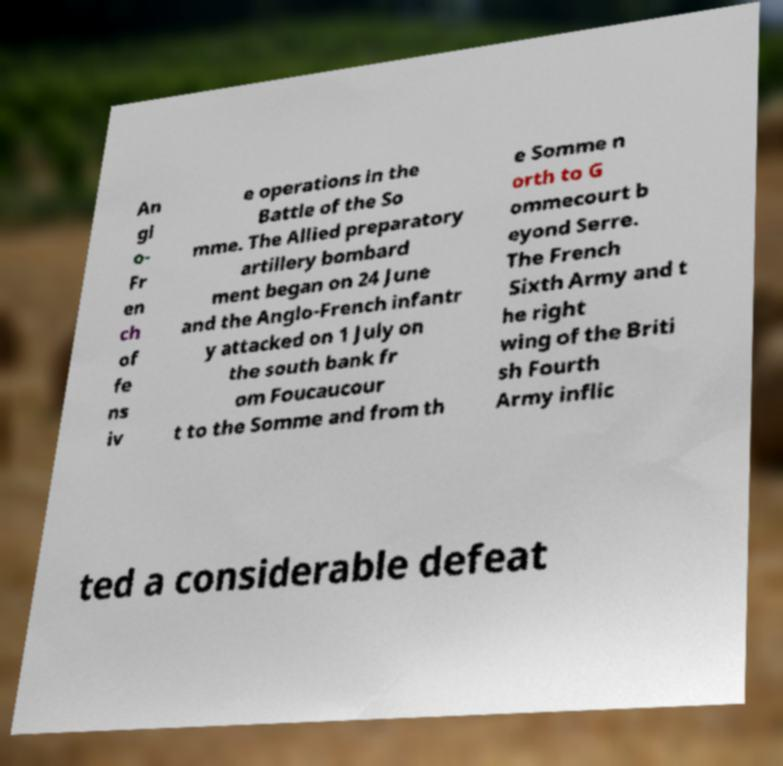Could you extract and type out the text from this image? An gl o- Fr en ch of fe ns iv e operations in the Battle of the So mme. The Allied preparatory artillery bombard ment began on 24 June and the Anglo-French infantr y attacked on 1 July on the south bank fr om Foucaucour t to the Somme and from th e Somme n orth to G ommecourt b eyond Serre. The French Sixth Army and t he right wing of the Briti sh Fourth Army inflic ted a considerable defeat 